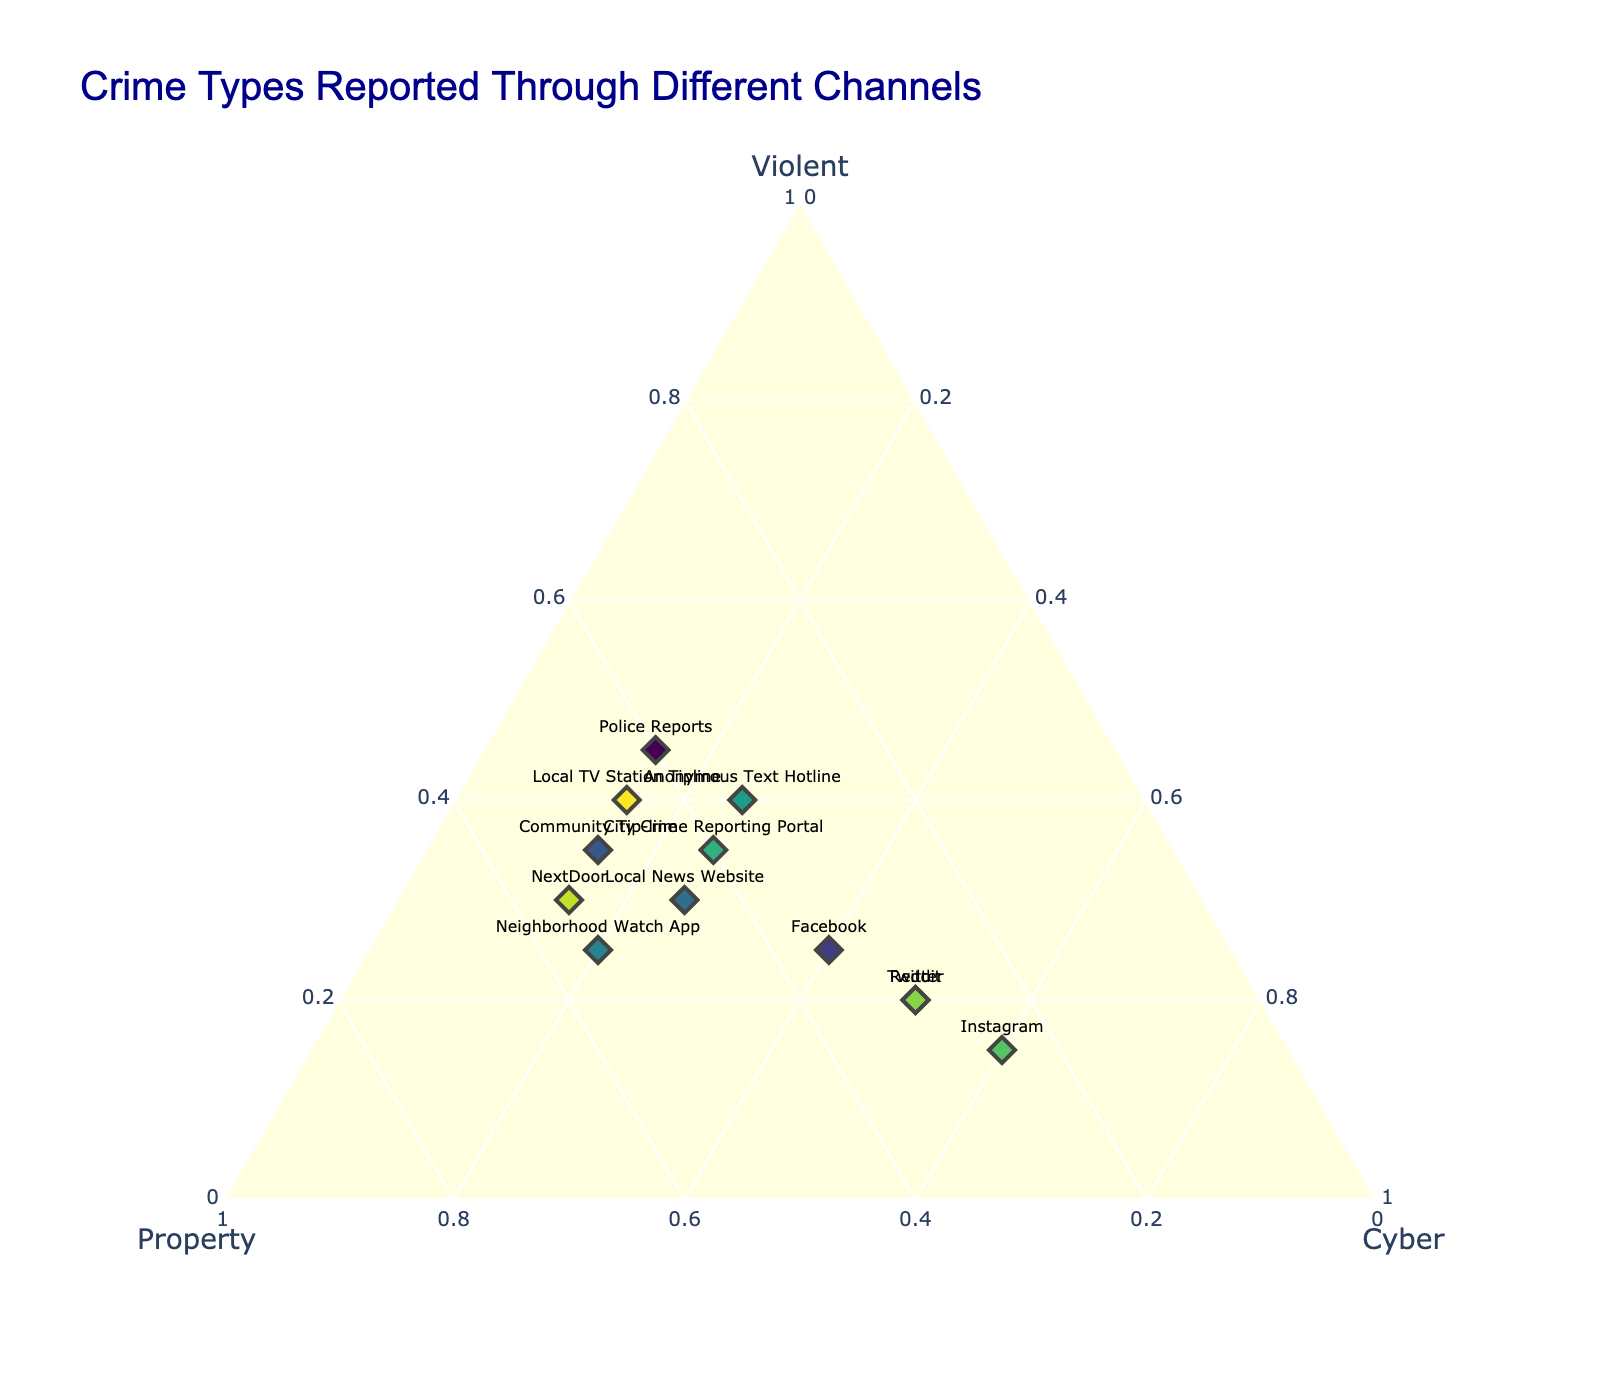What is the title of the ternary plot? The title is shown at the top of the figure.
Answer: "Crime Types Reported Through Different Channels" How many channels are depicted in the ternary plot? Count the number of different markers in the plot.
Answer: 12 Which channel reports the highest proportion of cyber crimes? Locate the marker closest to the "Cyber" axis.
Answer: Instagram What is the relative ordering of "Police Reports", "Facebook", and "Reddit" in terms of cyber crimes? Identify their positions relative to the "Cyber" axis and compare.
Answer: Reddit > Facebook > Police Reports Which channel has the least violent crime reports? Look for the marker closest to the "Property" and "Cyber" axes.
Answer: Instagram Between "Community Tip-line" and "NextDoor", which has a higher proportion of property crimes? Compare their positions relative to the "Property" axis.
Answer: NextDoor What is the typical range of property crimes reported through these channels? Look for the spread along the "Property" axis.
Answer: 25% to 55% Which two channels have an equal proportion of cyber crimes? Find markers that are at the same level along the "Cyber" axis.
Answer: Twitter and Reddit What is the average proportion of violent crime reports across all channels? Sum the percentages in the "Violent" column and divide by the number of channels.
Answer: 30% How do community sources ("Community Tip-line", "Neighborhood Watch App", "NextDoor") compare in terms of violent crime reporting? Compare their relative positions along the "Violent" axis.
Answer: Community Tip-line = 35%, Neighborhood Watch App = 25%, NextDoor = 30% 